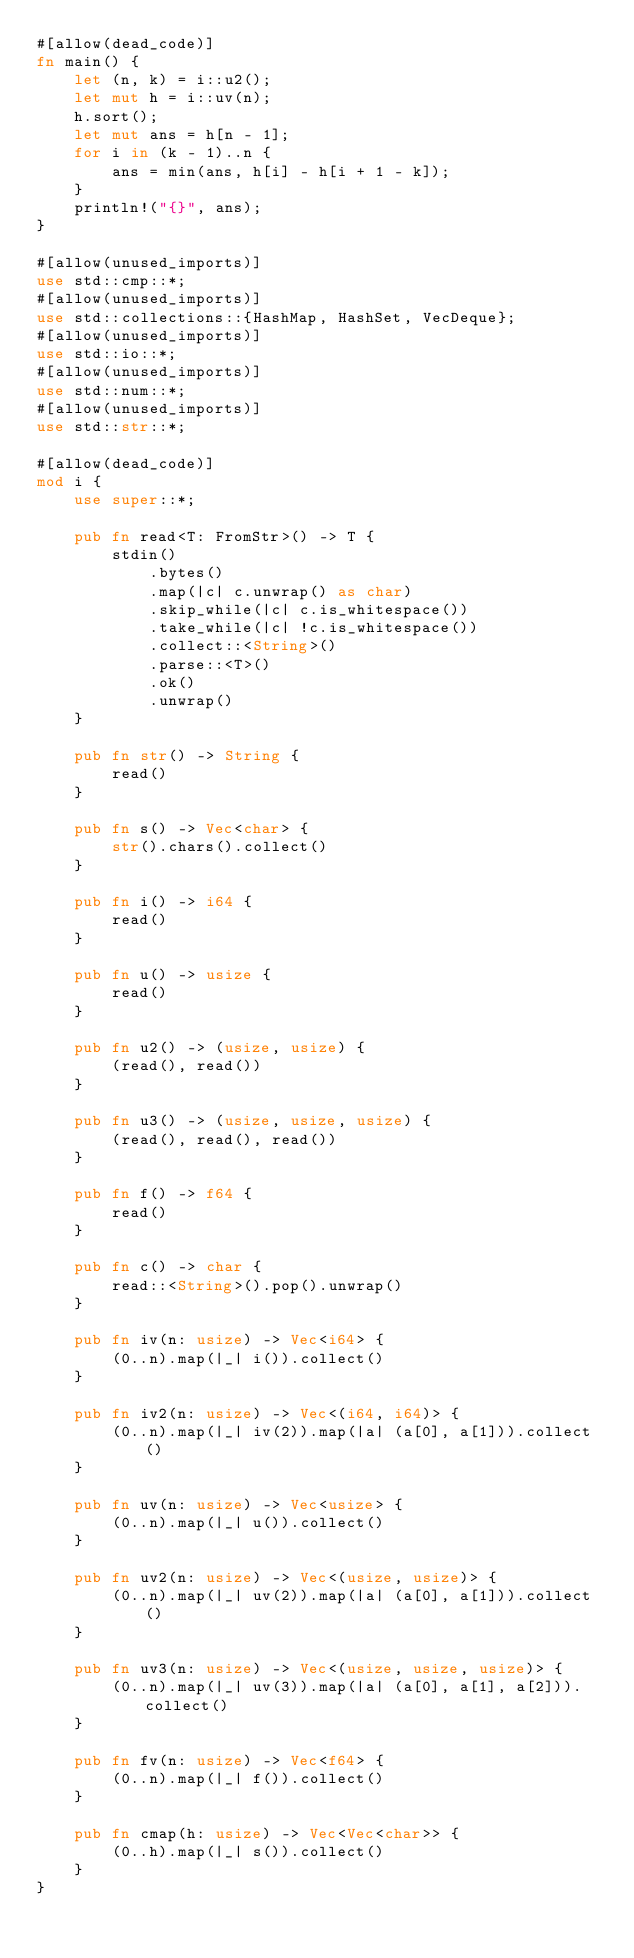Convert code to text. <code><loc_0><loc_0><loc_500><loc_500><_Rust_>#[allow(dead_code)]
fn main() {
    let (n, k) = i::u2();
    let mut h = i::uv(n);
    h.sort();
    let mut ans = h[n - 1];
    for i in (k - 1)..n {
        ans = min(ans, h[i] - h[i + 1 - k]);
    }
    println!("{}", ans);
}

#[allow(unused_imports)]
use std::cmp::*;
#[allow(unused_imports)]
use std::collections::{HashMap, HashSet, VecDeque};
#[allow(unused_imports)]
use std::io::*;
#[allow(unused_imports)]
use std::num::*;
#[allow(unused_imports)]
use std::str::*;

#[allow(dead_code)]
mod i {
    use super::*;

    pub fn read<T: FromStr>() -> T {
        stdin()
            .bytes()
            .map(|c| c.unwrap() as char)
            .skip_while(|c| c.is_whitespace())
            .take_while(|c| !c.is_whitespace())
            .collect::<String>()
            .parse::<T>()
            .ok()
            .unwrap()
    }

    pub fn str() -> String {
        read()
    }

    pub fn s() -> Vec<char> {
        str().chars().collect()
    }

    pub fn i() -> i64 {
        read()
    }

    pub fn u() -> usize {
        read()
    }

    pub fn u2() -> (usize, usize) {
        (read(), read())
    }

    pub fn u3() -> (usize, usize, usize) {
        (read(), read(), read())
    }

    pub fn f() -> f64 {
        read()
    }

    pub fn c() -> char {
        read::<String>().pop().unwrap()
    }

    pub fn iv(n: usize) -> Vec<i64> {
        (0..n).map(|_| i()).collect()
    }

    pub fn iv2(n: usize) -> Vec<(i64, i64)> {
        (0..n).map(|_| iv(2)).map(|a| (a[0], a[1])).collect()
    }

    pub fn uv(n: usize) -> Vec<usize> {
        (0..n).map(|_| u()).collect()
    }

    pub fn uv2(n: usize) -> Vec<(usize, usize)> {
        (0..n).map(|_| uv(2)).map(|a| (a[0], a[1])).collect()
    }

    pub fn uv3(n: usize) -> Vec<(usize, usize, usize)> {
        (0..n).map(|_| uv(3)).map(|a| (a[0], a[1], a[2])).collect()
    }

    pub fn fv(n: usize) -> Vec<f64> {
        (0..n).map(|_| f()).collect()
    }

    pub fn cmap(h: usize) -> Vec<Vec<char>> {
        (0..h).map(|_| s()).collect()
    }
}
</code> 